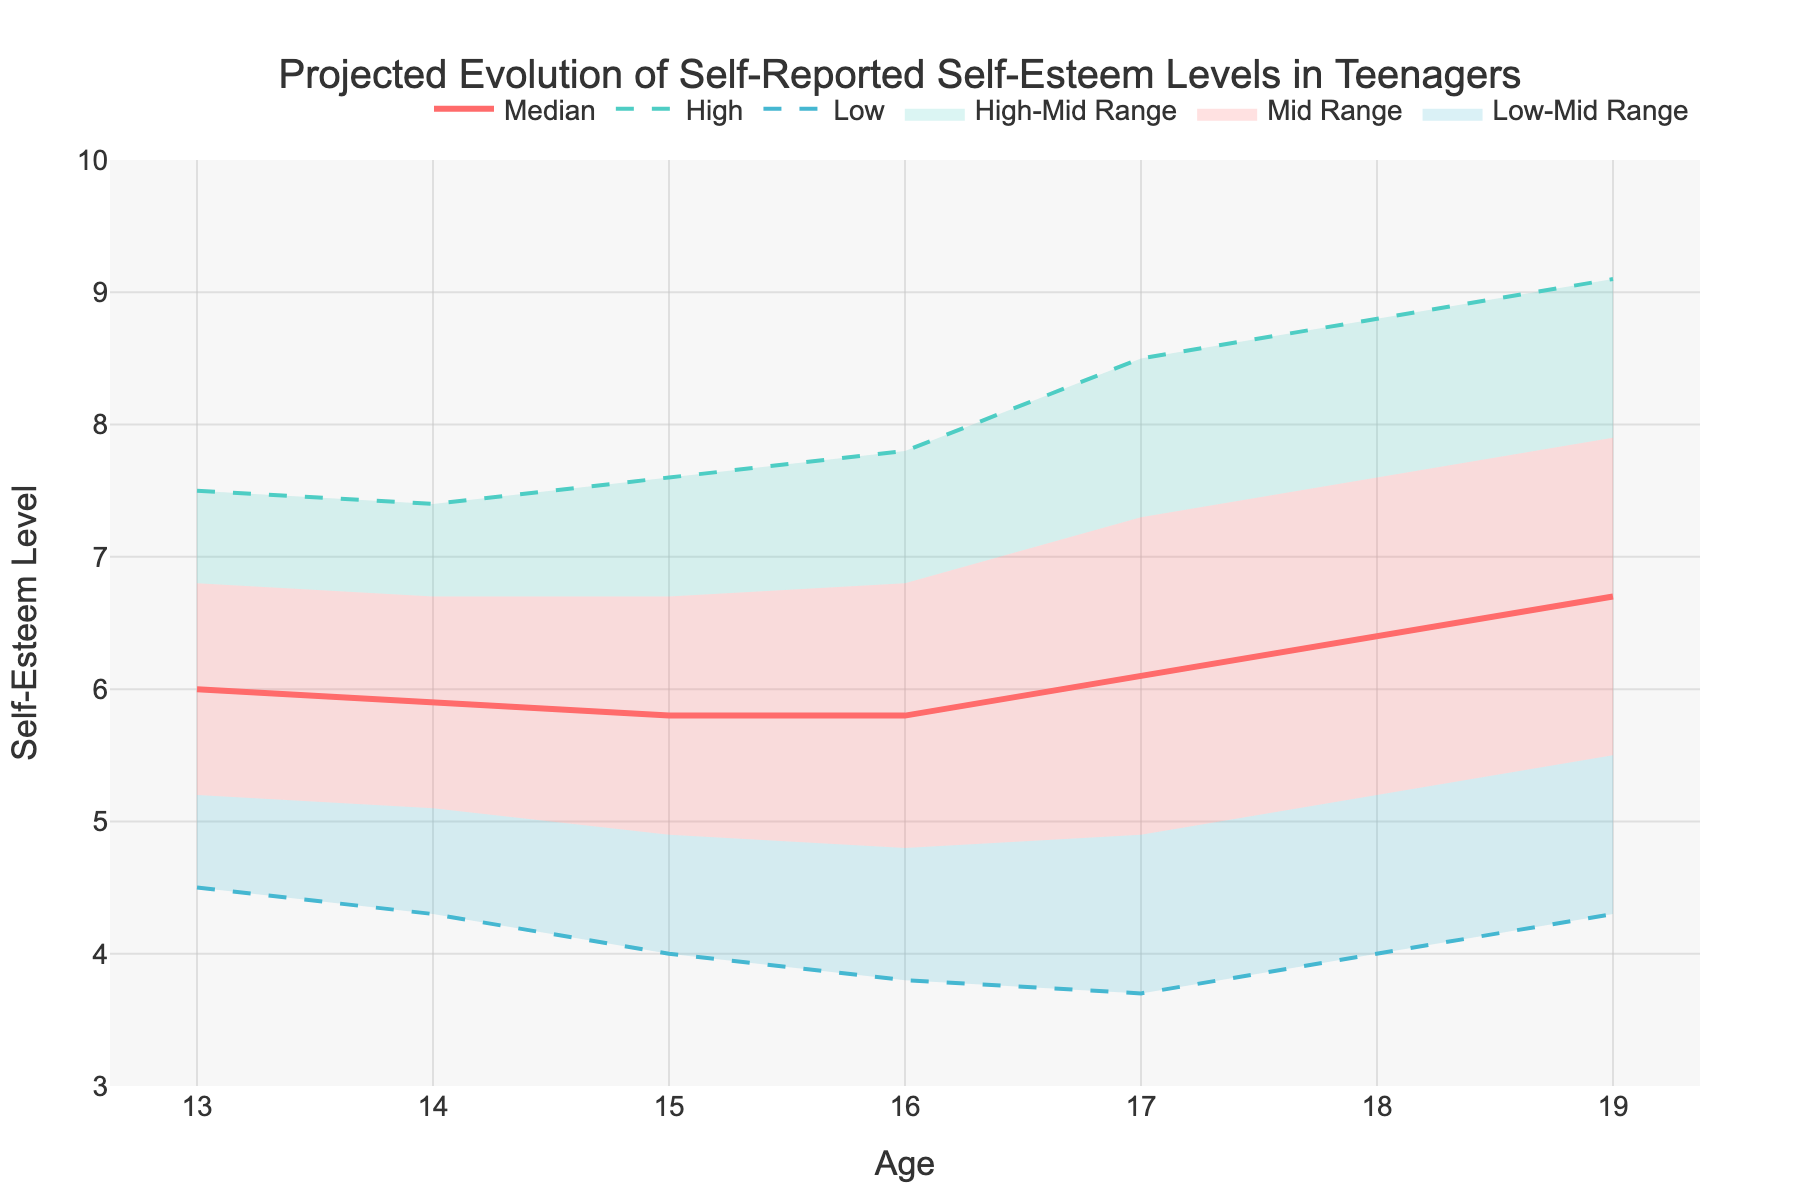What is the title of the figure? The title is prominently displayed at the top of the figure. It reads "Projected Evolution of Self-Reported Self-Esteem Levels in Teenagers."
Answer: Projected Evolution of Self-Reported Self-Esteem Levels in Teenagers What is the y-axis label? The y-axis label is found by looking at the vertical axis on the left side of the figure. It reads "Self-Esteem Level."
Answer: Self-Esteem Level How many age points are plotted in the figure? The data shows ages from 13 to 19, so count each age increment between these values.
Answer: 7 Which line represents the median self-esteem level? By examining the legend in the figure, you can see the "Median" line is represented.
Answer: The red line What is the estimated range of self-esteem levels for 17-year-olds? Look at the values for 17-year-olds. The high value is 8.5 and the low value is 3.7, therefore the range is between these values.
Answer: 3.7 to 8.5 How does the median self-esteem level change from age 13 to age 19? By observing the "Median" line, it starts at a higher value around 6 and gradually increases to around 6.7. This shows an increasing trend.
Answer: Increases What is the difference between the high and low self-esteem levels at age 18? Subtract the low value at age 18 (4.0) from the high value at age 18 (8.8) to find the difference.
Answer: 4.8 What trend can be seen in the high self-esteem levels from age 13 to age 19? The "High" line initially decreases slightly from age 13 to age 16 and then significantly increases from age 17 to age 19.
Answer: Decrease then increase Compare the self-esteem change between ages 14 and 16 for the "Mid-High" and "Low-Mid" categories. For "Mid-High," find the values at age 14 and 16 and compute the difference. Do the same for "Low-Mid." "Mid-High" decreases slightly, while "Low-Mid" shows an increase.
Answer: "Mid-High" decreases, "Low-Mid" increases What is the estimated self-esteem level for the upper quartile of 15-year-olds? The upper quartile is around the "Mid-High" range, which is approximately 6.7 for 15-year-olds.
Answer: Approximately 6.7 